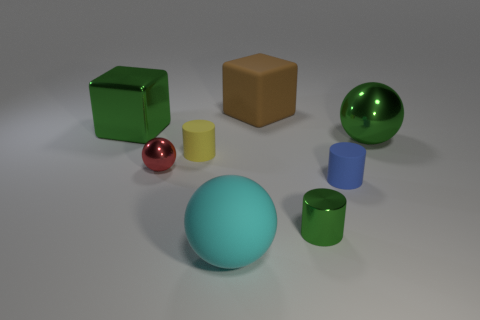What is the size of the yellow matte cylinder?
Offer a very short reply. Small. What number of cyan matte things are the same size as the brown rubber cube?
Ensure brevity in your answer.  1. Does the metallic cylinder have the same color as the big shiny block?
Keep it short and to the point. Yes. Is the large green thing that is on the left side of the cyan thing made of the same material as the big brown thing behind the small blue cylinder?
Keep it short and to the point. No. Is the number of green things greater than the number of objects?
Provide a succinct answer. No. Are there any other things that have the same color as the big metal ball?
Make the answer very short. Yes. Are the blue cylinder and the large cyan thing made of the same material?
Provide a short and direct response. Yes. Are there fewer big cyan balls than small gray cylinders?
Your answer should be very brief. No. Do the yellow matte thing and the blue thing have the same shape?
Your answer should be very brief. Yes. What color is the small metal ball?
Offer a very short reply. Red. 